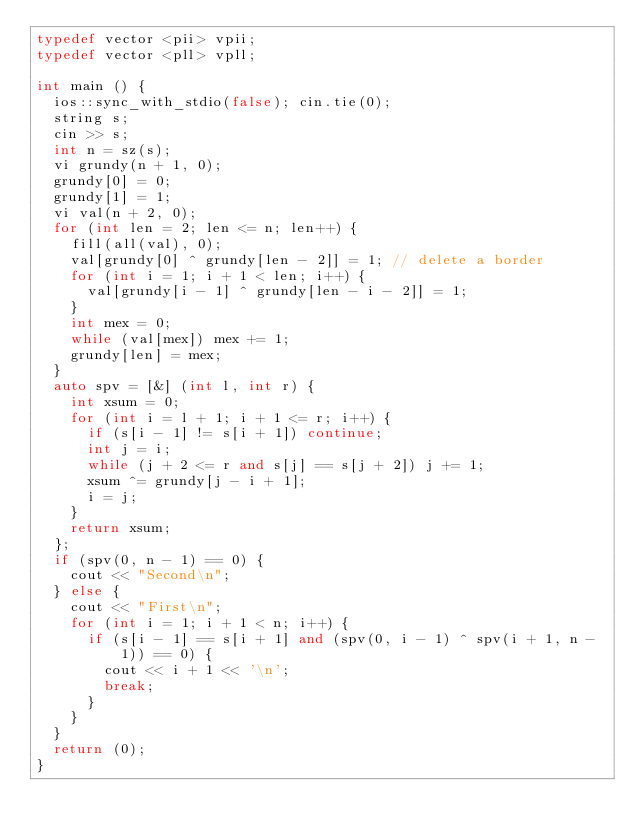<code> <loc_0><loc_0><loc_500><loc_500><_C++_>typedef vector <pii> vpii;
typedef vector <pll> vpll;

int main () {
  ios::sync_with_stdio(false); cin.tie(0);
  string s;
  cin >> s;
  int n = sz(s);
  vi grundy(n + 1, 0);
  grundy[0] = 0;
  grundy[1] = 1;
  vi val(n + 2, 0);
  for (int len = 2; len <= n; len++) {
    fill(all(val), 0);
    val[grundy[0] ^ grundy[len - 2]] = 1; // delete a border
    for (int i = 1; i + 1 < len; i++) {
      val[grundy[i - 1] ^ grundy[len - i - 2]] = 1;
    }
    int mex = 0;
    while (val[mex]) mex += 1;
    grundy[len] = mex;
  }
  auto spv = [&] (int l, int r) {
    int xsum = 0;
    for (int i = l + 1; i + 1 <= r; i++) {
      if (s[i - 1] != s[i + 1]) continue;
      int j = i;
      while (j + 2 <= r and s[j] == s[j + 2]) j += 1;
      xsum ^= grundy[j - i + 1];
      i = j;
    }
    return xsum;
  };
  if (spv(0, n - 1) == 0) {
    cout << "Second\n";
  } else {
    cout << "First\n";
    for (int i = 1; i + 1 < n; i++) {
      if (s[i - 1] == s[i + 1] and (spv(0, i - 1) ^ spv(i + 1, n - 1)) == 0) {
        cout << i + 1 << '\n';
        break;
      }
    }
  }
  return (0);
}
</code> 